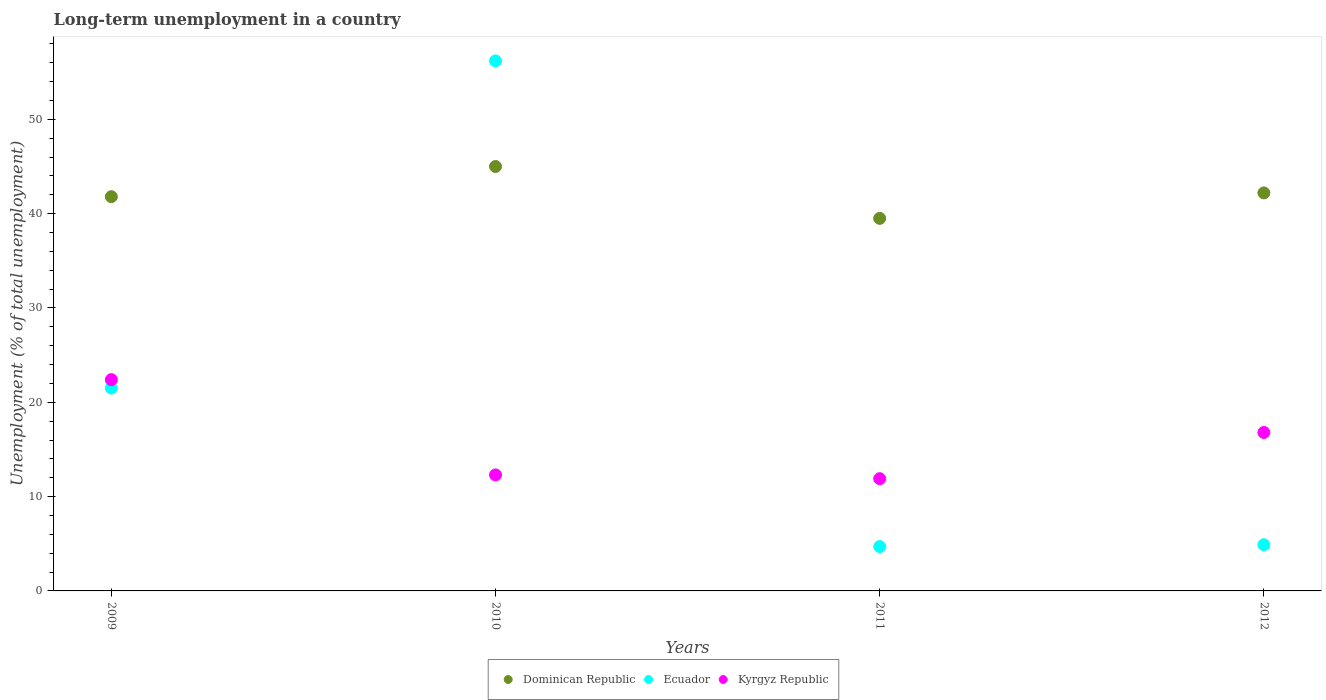How many different coloured dotlines are there?
Your answer should be compact. 3. Is the number of dotlines equal to the number of legend labels?
Provide a short and direct response. Yes. What is the percentage of long-term unemployed population in Dominican Republic in 2010?
Your answer should be very brief. 45. Across all years, what is the maximum percentage of long-term unemployed population in Kyrgyz Republic?
Offer a very short reply. 22.4. Across all years, what is the minimum percentage of long-term unemployed population in Dominican Republic?
Make the answer very short. 39.5. In which year was the percentage of long-term unemployed population in Kyrgyz Republic maximum?
Provide a succinct answer. 2009. What is the total percentage of long-term unemployed population in Dominican Republic in the graph?
Keep it short and to the point. 168.5. What is the difference between the percentage of long-term unemployed population in Kyrgyz Republic in 2011 and that in 2012?
Offer a very short reply. -4.9. What is the difference between the percentage of long-term unemployed population in Kyrgyz Republic in 2012 and the percentage of long-term unemployed population in Dominican Republic in 2010?
Give a very brief answer. -28.2. What is the average percentage of long-term unemployed population in Kyrgyz Republic per year?
Your answer should be compact. 15.85. In the year 2012, what is the difference between the percentage of long-term unemployed population in Dominican Republic and percentage of long-term unemployed population in Kyrgyz Republic?
Provide a succinct answer. 25.4. In how many years, is the percentage of long-term unemployed population in Dominican Republic greater than 34 %?
Your answer should be very brief. 4. What is the ratio of the percentage of long-term unemployed population in Dominican Republic in 2009 to that in 2012?
Your answer should be compact. 0.99. What is the difference between the highest and the second highest percentage of long-term unemployed population in Dominican Republic?
Offer a terse response. 2.8. What is the difference between the highest and the lowest percentage of long-term unemployed population in Dominican Republic?
Your answer should be very brief. 5.5. In how many years, is the percentage of long-term unemployed population in Ecuador greater than the average percentage of long-term unemployed population in Ecuador taken over all years?
Provide a succinct answer. 1. Is the sum of the percentage of long-term unemployed population in Ecuador in 2011 and 2012 greater than the maximum percentage of long-term unemployed population in Dominican Republic across all years?
Provide a succinct answer. No. Is it the case that in every year, the sum of the percentage of long-term unemployed population in Ecuador and percentage of long-term unemployed population in Dominican Republic  is greater than the percentage of long-term unemployed population in Kyrgyz Republic?
Your response must be concise. Yes. Is the percentage of long-term unemployed population in Ecuador strictly greater than the percentage of long-term unemployed population in Dominican Republic over the years?
Keep it short and to the point. No. How many dotlines are there?
Your answer should be compact. 3. How many years are there in the graph?
Ensure brevity in your answer.  4. What is the difference between two consecutive major ticks on the Y-axis?
Make the answer very short. 10. Does the graph contain any zero values?
Your answer should be compact. No. Where does the legend appear in the graph?
Offer a very short reply. Bottom center. How many legend labels are there?
Offer a terse response. 3. How are the legend labels stacked?
Your answer should be compact. Horizontal. What is the title of the graph?
Your response must be concise. Long-term unemployment in a country. Does "Congo (Democratic)" appear as one of the legend labels in the graph?
Your answer should be very brief. No. What is the label or title of the X-axis?
Provide a succinct answer. Years. What is the label or title of the Y-axis?
Your answer should be very brief. Unemployment (% of total unemployment). What is the Unemployment (% of total unemployment) of Dominican Republic in 2009?
Offer a terse response. 41.8. What is the Unemployment (% of total unemployment) in Ecuador in 2009?
Your answer should be very brief. 21.5. What is the Unemployment (% of total unemployment) of Kyrgyz Republic in 2009?
Your response must be concise. 22.4. What is the Unemployment (% of total unemployment) in Ecuador in 2010?
Your answer should be very brief. 56.2. What is the Unemployment (% of total unemployment) in Kyrgyz Republic in 2010?
Provide a short and direct response. 12.3. What is the Unemployment (% of total unemployment) of Dominican Republic in 2011?
Provide a succinct answer. 39.5. What is the Unemployment (% of total unemployment) in Ecuador in 2011?
Provide a succinct answer. 4.7. What is the Unemployment (% of total unemployment) in Kyrgyz Republic in 2011?
Offer a very short reply. 11.9. What is the Unemployment (% of total unemployment) of Dominican Republic in 2012?
Keep it short and to the point. 42.2. What is the Unemployment (% of total unemployment) of Ecuador in 2012?
Provide a short and direct response. 4.9. What is the Unemployment (% of total unemployment) of Kyrgyz Republic in 2012?
Give a very brief answer. 16.8. Across all years, what is the maximum Unemployment (% of total unemployment) of Dominican Republic?
Your response must be concise. 45. Across all years, what is the maximum Unemployment (% of total unemployment) of Ecuador?
Ensure brevity in your answer.  56.2. Across all years, what is the maximum Unemployment (% of total unemployment) of Kyrgyz Republic?
Make the answer very short. 22.4. Across all years, what is the minimum Unemployment (% of total unemployment) of Dominican Republic?
Provide a succinct answer. 39.5. Across all years, what is the minimum Unemployment (% of total unemployment) in Ecuador?
Offer a very short reply. 4.7. Across all years, what is the minimum Unemployment (% of total unemployment) of Kyrgyz Republic?
Offer a very short reply. 11.9. What is the total Unemployment (% of total unemployment) of Dominican Republic in the graph?
Keep it short and to the point. 168.5. What is the total Unemployment (% of total unemployment) in Ecuador in the graph?
Your answer should be very brief. 87.3. What is the total Unemployment (% of total unemployment) in Kyrgyz Republic in the graph?
Your answer should be compact. 63.4. What is the difference between the Unemployment (% of total unemployment) of Ecuador in 2009 and that in 2010?
Your response must be concise. -34.7. What is the difference between the Unemployment (% of total unemployment) of Kyrgyz Republic in 2009 and that in 2011?
Ensure brevity in your answer.  10.5. What is the difference between the Unemployment (% of total unemployment) of Dominican Republic in 2009 and that in 2012?
Make the answer very short. -0.4. What is the difference between the Unemployment (% of total unemployment) of Kyrgyz Republic in 2009 and that in 2012?
Provide a succinct answer. 5.6. What is the difference between the Unemployment (% of total unemployment) in Dominican Republic in 2010 and that in 2011?
Your answer should be compact. 5.5. What is the difference between the Unemployment (% of total unemployment) in Ecuador in 2010 and that in 2011?
Provide a succinct answer. 51.5. What is the difference between the Unemployment (% of total unemployment) of Dominican Republic in 2010 and that in 2012?
Provide a short and direct response. 2.8. What is the difference between the Unemployment (% of total unemployment) of Ecuador in 2010 and that in 2012?
Offer a very short reply. 51.3. What is the difference between the Unemployment (% of total unemployment) of Ecuador in 2011 and that in 2012?
Ensure brevity in your answer.  -0.2. What is the difference between the Unemployment (% of total unemployment) in Kyrgyz Republic in 2011 and that in 2012?
Keep it short and to the point. -4.9. What is the difference between the Unemployment (% of total unemployment) of Dominican Republic in 2009 and the Unemployment (% of total unemployment) of Ecuador in 2010?
Your answer should be compact. -14.4. What is the difference between the Unemployment (% of total unemployment) in Dominican Republic in 2009 and the Unemployment (% of total unemployment) in Kyrgyz Republic in 2010?
Provide a succinct answer. 29.5. What is the difference between the Unemployment (% of total unemployment) in Ecuador in 2009 and the Unemployment (% of total unemployment) in Kyrgyz Republic in 2010?
Offer a very short reply. 9.2. What is the difference between the Unemployment (% of total unemployment) of Dominican Republic in 2009 and the Unemployment (% of total unemployment) of Ecuador in 2011?
Provide a succinct answer. 37.1. What is the difference between the Unemployment (% of total unemployment) of Dominican Republic in 2009 and the Unemployment (% of total unemployment) of Kyrgyz Republic in 2011?
Keep it short and to the point. 29.9. What is the difference between the Unemployment (% of total unemployment) in Ecuador in 2009 and the Unemployment (% of total unemployment) in Kyrgyz Republic in 2011?
Your answer should be compact. 9.6. What is the difference between the Unemployment (% of total unemployment) of Dominican Republic in 2009 and the Unemployment (% of total unemployment) of Ecuador in 2012?
Your response must be concise. 36.9. What is the difference between the Unemployment (% of total unemployment) of Ecuador in 2009 and the Unemployment (% of total unemployment) of Kyrgyz Republic in 2012?
Offer a very short reply. 4.7. What is the difference between the Unemployment (% of total unemployment) of Dominican Republic in 2010 and the Unemployment (% of total unemployment) of Ecuador in 2011?
Your answer should be compact. 40.3. What is the difference between the Unemployment (% of total unemployment) of Dominican Republic in 2010 and the Unemployment (% of total unemployment) of Kyrgyz Republic in 2011?
Keep it short and to the point. 33.1. What is the difference between the Unemployment (% of total unemployment) in Ecuador in 2010 and the Unemployment (% of total unemployment) in Kyrgyz Republic in 2011?
Offer a terse response. 44.3. What is the difference between the Unemployment (% of total unemployment) of Dominican Republic in 2010 and the Unemployment (% of total unemployment) of Ecuador in 2012?
Make the answer very short. 40.1. What is the difference between the Unemployment (% of total unemployment) in Dominican Republic in 2010 and the Unemployment (% of total unemployment) in Kyrgyz Republic in 2012?
Give a very brief answer. 28.2. What is the difference between the Unemployment (% of total unemployment) of Ecuador in 2010 and the Unemployment (% of total unemployment) of Kyrgyz Republic in 2012?
Offer a very short reply. 39.4. What is the difference between the Unemployment (% of total unemployment) of Dominican Republic in 2011 and the Unemployment (% of total unemployment) of Ecuador in 2012?
Provide a short and direct response. 34.6. What is the difference between the Unemployment (% of total unemployment) of Dominican Republic in 2011 and the Unemployment (% of total unemployment) of Kyrgyz Republic in 2012?
Your response must be concise. 22.7. What is the average Unemployment (% of total unemployment) of Dominican Republic per year?
Your response must be concise. 42.12. What is the average Unemployment (% of total unemployment) in Ecuador per year?
Make the answer very short. 21.82. What is the average Unemployment (% of total unemployment) of Kyrgyz Republic per year?
Make the answer very short. 15.85. In the year 2009, what is the difference between the Unemployment (% of total unemployment) of Dominican Republic and Unemployment (% of total unemployment) of Ecuador?
Offer a terse response. 20.3. In the year 2009, what is the difference between the Unemployment (% of total unemployment) in Dominican Republic and Unemployment (% of total unemployment) in Kyrgyz Republic?
Your answer should be compact. 19.4. In the year 2010, what is the difference between the Unemployment (% of total unemployment) of Dominican Republic and Unemployment (% of total unemployment) of Ecuador?
Keep it short and to the point. -11.2. In the year 2010, what is the difference between the Unemployment (% of total unemployment) in Dominican Republic and Unemployment (% of total unemployment) in Kyrgyz Republic?
Ensure brevity in your answer.  32.7. In the year 2010, what is the difference between the Unemployment (% of total unemployment) in Ecuador and Unemployment (% of total unemployment) in Kyrgyz Republic?
Offer a terse response. 43.9. In the year 2011, what is the difference between the Unemployment (% of total unemployment) of Dominican Republic and Unemployment (% of total unemployment) of Ecuador?
Your answer should be very brief. 34.8. In the year 2011, what is the difference between the Unemployment (% of total unemployment) in Dominican Republic and Unemployment (% of total unemployment) in Kyrgyz Republic?
Your response must be concise. 27.6. In the year 2012, what is the difference between the Unemployment (% of total unemployment) in Dominican Republic and Unemployment (% of total unemployment) in Ecuador?
Provide a short and direct response. 37.3. In the year 2012, what is the difference between the Unemployment (% of total unemployment) in Dominican Republic and Unemployment (% of total unemployment) in Kyrgyz Republic?
Ensure brevity in your answer.  25.4. What is the ratio of the Unemployment (% of total unemployment) of Dominican Republic in 2009 to that in 2010?
Provide a short and direct response. 0.93. What is the ratio of the Unemployment (% of total unemployment) of Ecuador in 2009 to that in 2010?
Offer a terse response. 0.38. What is the ratio of the Unemployment (% of total unemployment) of Kyrgyz Republic in 2009 to that in 2010?
Ensure brevity in your answer.  1.82. What is the ratio of the Unemployment (% of total unemployment) in Dominican Republic in 2009 to that in 2011?
Offer a terse response. 1.06. What is the ratio of the Unemployment (% of total unemployment) of Ecuador in 2009 to that in 2011?
Ensure brevity in your answer.  4.57. What is the ratio of the Unemployment (% of total unemployment) in Kyrgyz Republic in 2009 to that in 2011?
Provide a short and direct response. 1.88. What is the ratio of the Unemployment (% of total unemployment) of Ecuador in 2009 to that in 2012?
Ensure brevity in your answer.  4.39. What is the ratio of the Unemployment (% of total unemployment) in Dominican Republic in 2010 to that in 2011?
Your answer should be compact. 1.14. What is the ratio of the Unemployment (% of total unemployment) in Ecuador in 2010 to that in 2011?
Ensure brevity in your answer.  11.96. What is the ratio of the Unemployment (% of total unemployment) of Kyrgyz Republic in 2010 to that in 2011?
Make the answer very short. 1.03. What is the ratio of the Unemployment (% of total unemployment) in Dominican Republic in 2010 to that in 2012?
Provide a short and direct response. 1.07. What is the ratio of the Unemployment (% of total unemployment) of Ecuador in 2010 to that in 2012?
Offer a terse response. 11.47. What is the ratio of the Unemployment (% of total unemployment) of Kyrgyz Republic in 2010 to that in 2012?
Provide a succinct answer. 0.73. What is the ratio of the Unemployment (% of total unemployment) in Dominican Republic in 2011 to that in 2012?
Your answer should be very brief. 0.94. What is the ratio of the Unemployment (% of total unemployment) of Ecuador in 2011 to that in 2012?
Make the answer very short. 0.96. What is the ratio of the Unemployment (% of total unemployment) in Kyrgyz Republic in 2011 to that in 2012?
Your answer should be very brief. 0.71. What is the difference between the highest and the second highest Unemployment (% of total unemployment) of Dominican Republic?
Provide a short and direct response. 2.8. What is the difference between the highest and the second highest Unemployment (% of total unemployment) of Ecuador?
Make the answer very short. 34.7. What is the difference between the highest and the lowest Unemployment (% of total unemployment) of Ecuador?
Provide a succinct answer. 51.5. What is the difference between the highest and the lowest Unemployment (% of total unemployment) of Kyrgyz Republic?
Give a very brief answer. 10.5. 